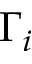Convert formula to latex. <formula><loc_0><loc_0><loc_500><loc_500>\Gamma _ { i }</formula> 